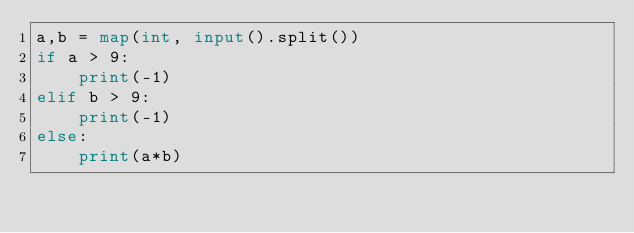Convert code to text. <code><loc_0><loc_0><loc_500><loc_500><_Python_>a,b = map(int, input().split())
if a > 9:
    print(-1)
elif b > 9:
    print(-1)
else:
    print(a*b)</code> 